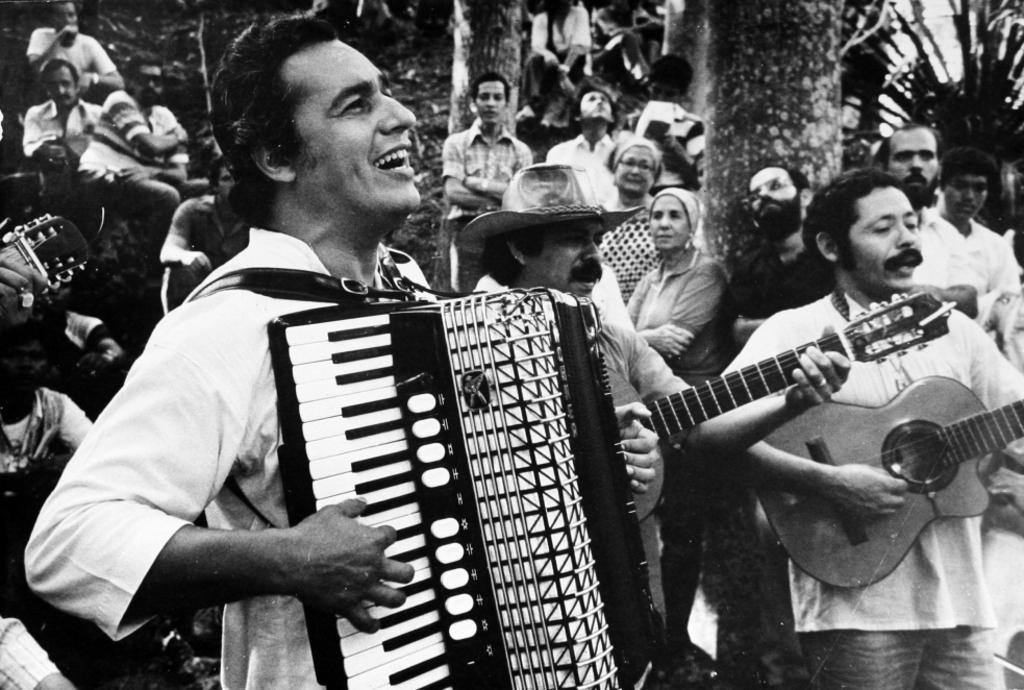Describe this image in one or two sentences. A black and white picture. Front this persons are playing a musical instrument. Far many persons are standing. 